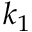<formula> <loc_0><loc_0><loc_500><loc_500>k _ { 1 }</formula> 